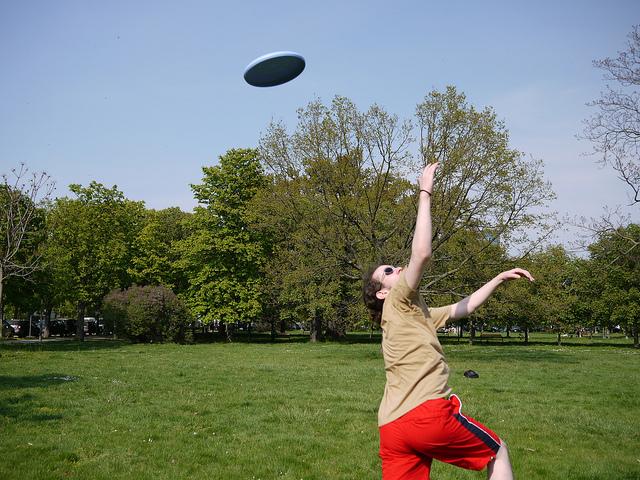Where are the sunglasses?
Give a very brief answer. Face. Is this in a park?
Be succinct. Yes. Is this man athletic?
Write a very short answer. Yes. 